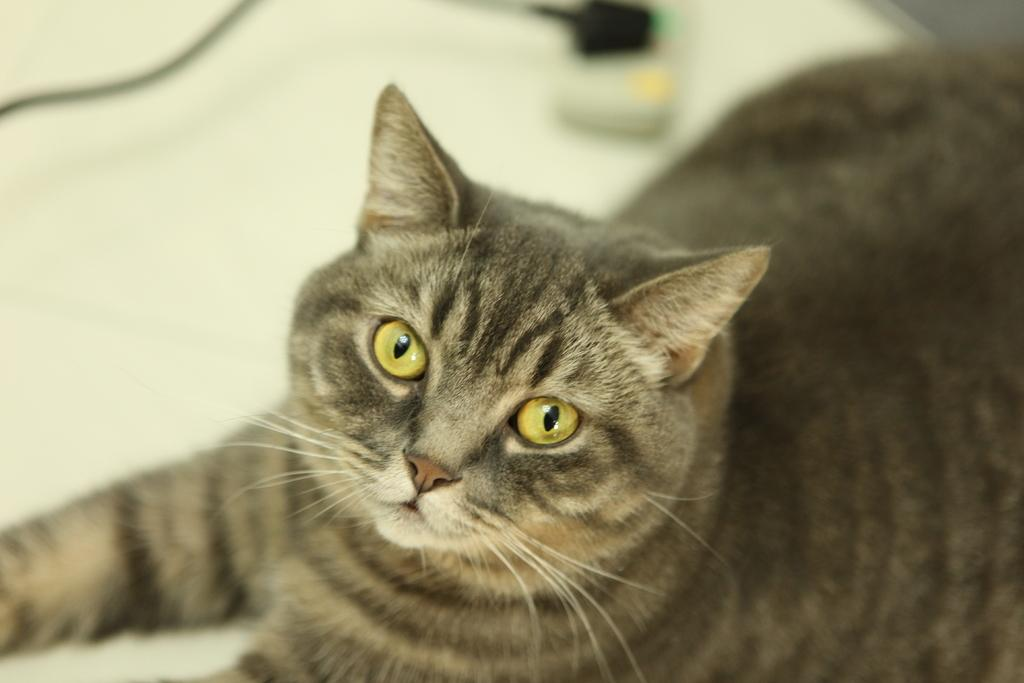What type of animal is in the picture? There is a cat in the picture. Can you describe the background of the image? The background of the image is blurred. What type of chalk is the cat using to draw on the wall in the image? There is no chalk or drawing on the wall in the image; it only features a cat. 